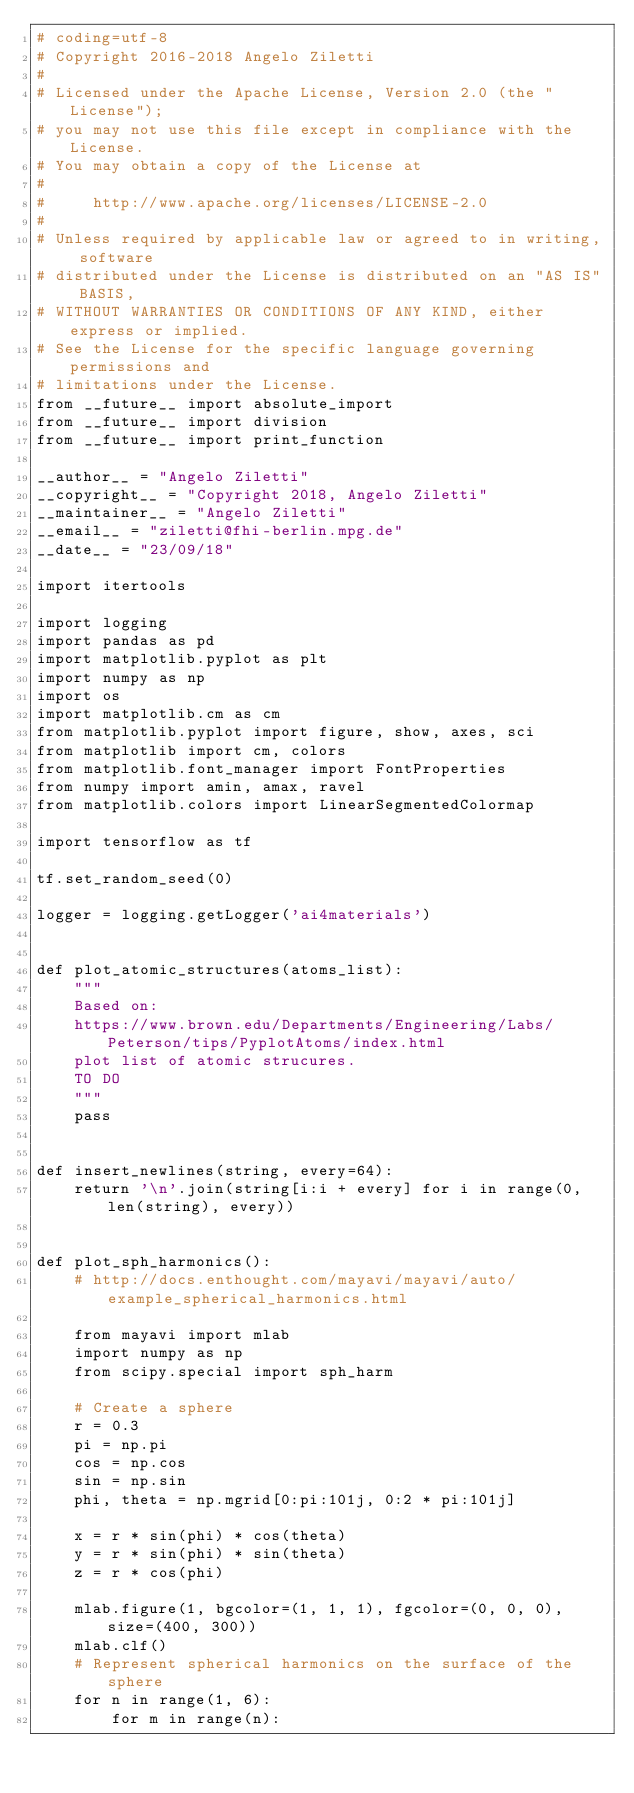<code> <loc_0><loc_0><loc_500><loc_500><_Python_># coding=utf-8
# Copyright 2016-2018 Angelo Ziletti
#
# Licensed under the Apache License, Version 2.0 (the "License");
# you may not use this file except in compliance with the License.
# You may obtain a copy of the License at
#
#     http://www.apache.org/licenses/LICENSE-2.0
#
# Unless required by applicable law or agreed to in writing, software
# distributed under the License is distributed on an "AS IS" BASIS,
# WITHOUT WARRANTIES OR CONDITIONS OF ANY KIND, either express or implied.
# See the License for the specific language governing permissions and
# limitations under the License.
from __future__ import absolute_import
from __future__ import division
from __future__ import print_function

__author__ = "Angelo Ziletti"
__copyright__ = "Copyright 2018, Angelo Ziletti"
__maintainer__ = "Angelo Ziletti"
__email__ = "ziletti@fhi-berlin.mpg.de"
__date__ = "23/09/18"

import itertools

import logging
import pandas as pd
import matplotlib.pyplot as plt
import numpy as np
import os
import matplotlib.cm as cm
from matplotlib.pyplot import figure, show, axes, sci
from matplotlib import cm, colors
from matplotlib.font_manager import FontProperties
from numpy import amin, amax, ravel
from matplotlib.colors import LinearSegmentedColormap

import tensorflow as tf

tf.set_random_seed(0)

logger = logging.getLogger('ai4materials')


def plot_atomic_structures(atoms_list):
    """
    Based on:
    https://www.brown.edu/Departments/Engineering/Labs/Peterson/tips/PyplotAtoms/index.html
    plot list of atomic strucures.
    TO DO
    """
    pass


def insert_newlines(string, every=64):
    return '\n'.join(string[i:i + every] for i in range(0, len(string), every))


def plot_sph_harmonics():
    # http://docs.enthought.com/mayavi/mayavi/auto/example_spherical_harmonics.html

    from mayavi import mlab
    import numpy as np
    from scipy.special import sph_harm

    # Create a sphere
    r = 0.3
    pi = np.pi
    cos = np.cos
    sin = np.sin
    phi, theta = np.mgrid[0:pi:101j, 0:2 * pi:101j]

    x = r * sin(phi) * cos(theta)
    y = r * sin(phi) * sin(theta)
    z = r * cos(phi)

    mlab.figure(1, bgcolor=(1, 1, 1), fgcolor=(0, 0, 0), size=(400, 300))
    mlab.clf()
    # Represent spherical harmonics on the surface of the sphere
    for n in range(1, 6):
        for m in range(n):</code> 